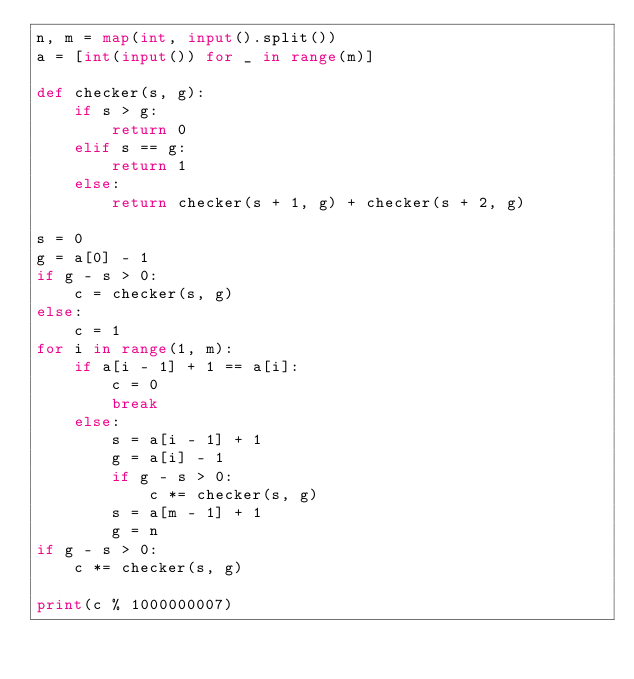Convert code to text. <code><loc_0><loc_0><loc_500><loc_500><_Python_>n, m = map(int, input().split())
a = [int(input()) for _ in range(m)]

def checker(s, g):
    if s > g:
        return 0
    elif s == g:
        return 1
    else:
        return checker(s + 1, g) + checker(s + 2, g)

s = 0
g = a[0] - 1
if g - s > 0:
    c = checker(s, g)
else:
    c = 1
for i in range(1, m):
    if a[i - 1] + 1 == a[i]:
        c = 0
        break
    else:
        s = a[i - 1] + 1
        g = a[i] - 1
        if g - s > 0:
            c *= checker(s, g)
        s = a[m - 1] + 1
        g = n
if g - s > 0:
    c *= checker(s, g)

print(c % 1000000007)
</code> 